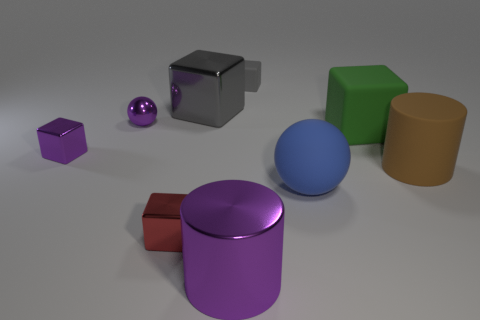How big is the ball that is on the left side of the matte block that is to the left of the blue rubber thing?
Your answer should be very brief. Small. Is the number of purple rubber cubes greater than the number of small purple balls?
Your answer should be compact. No. Do the metallic cube that is in front of the brown thing and the rubber ball have the same size?
Your response must be concise. No. How many balls have the same color as the big metal cylinder?
Provide a short and direct response. 1. Does the green matte thing have the same shape as the small red object?
Provide a short and direct response. Yes. There is a green thing that is the same shape as the gray shiny object; what is its size?
Provide a short and direct response. Large. Are there more tiny matte blocks that are to the right of the tiny purple block than tiny red objects on the right side of the tiny red metal block?
Make the answer very short. Yes. Does the blue object have the same material as the ball that is on the left side of the red shiny block?
Your answer should be compact. No. Is there anything else that has the same shape as the small gray matte thing?
Your response must be concise. Yes. There is a cube that is to the left of the large gray object and behind the blue matte object; what is its color?
Your response must be concise. Purple. 